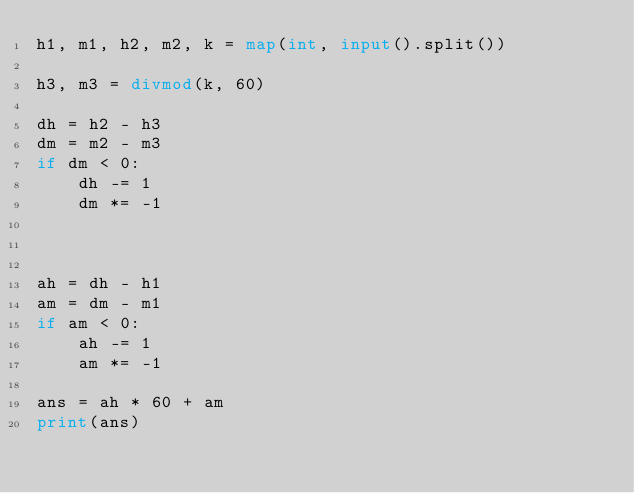<code> <loc_0><loc_0><loc_500><loc_500><_Python_>h1, m1, h2, m2, k = map(int, input().split())

h3, m3 = divmod(k, 60)

dh = h2 - h3
dm = m2 - m3
if dm < 0:
    dh -= 1
    dm *= -1



ah = dh - h1
am = dm - m1
if am < 0:
    ah -= 1
    am *= -1

ans = ah * 60 + am
print(ans)</code> 